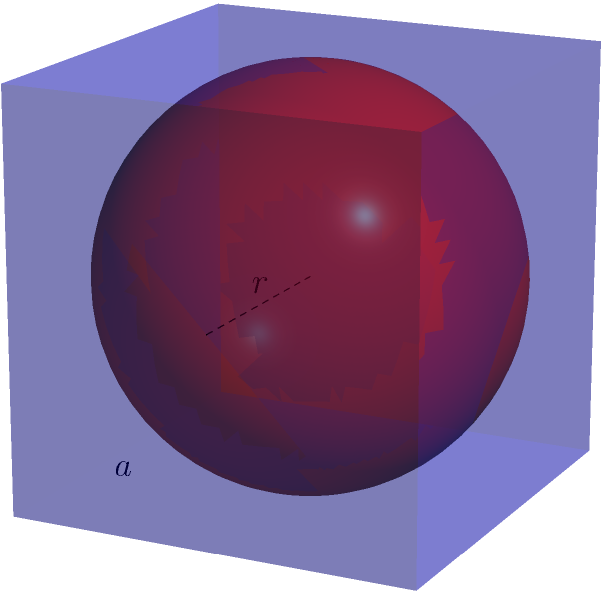In a library, knowledge is often contained within its walls, much like Hannah Arendt's ideas are contained within her books. Consider a cube-shaped library with side length $a$, and an inscribed sphere representing the knowledge within. If the sphere touches all sides of the cube, what is the volume of the sphere in terms of $a$? Let's approach this step-by-step:

1) First, we need to find the relationship between the cube's side length $a$ and the sphere's radius $r$.

2) In a cube with an inscribed sphere, the diameter of the sphere is equal to the side length of the cube. Therefore:

   $2r = a$ or $r = \frac{a}{2}$

3) The volume of a sphere is given by the formula:

   $V_{sphere} = \frac{4}{3}\pi r^3$

4) Substituting $r = \frac{a}{2}$ into this formula:

   $V_{sphere} = \frac{4}{3}\pi (\frac{a}{2})^3$

5) Simplify:
   $V_{sphere} = \frac{4}{3}\pi \frac{a^3}{8}$
   $V_{sphere} = \frac{1}{6}\pi a^3$

Therefore, the volume of the sphere inscribed in the cube is $\frac{1}{6}\pi a^3$.
Answer: $\frac{1}{6}\pi a^3$ 